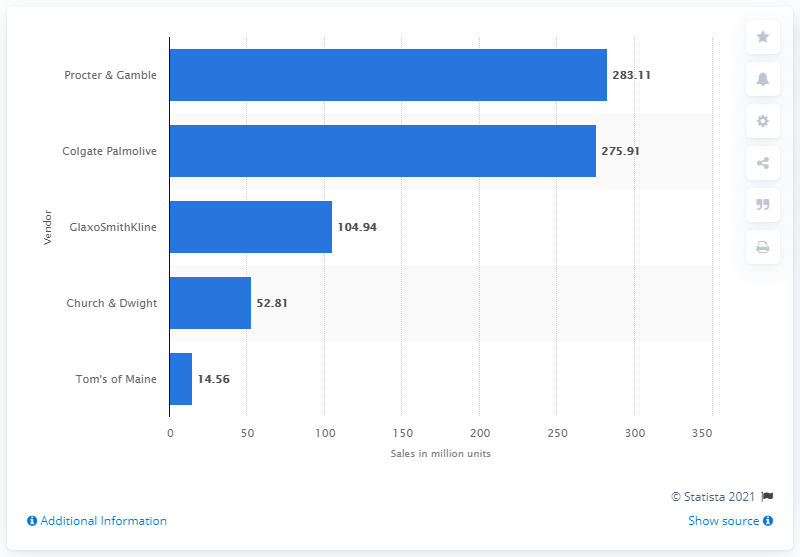Point out several critical features in this image. Procter & Gamble sold 283,110 units in 2020. 